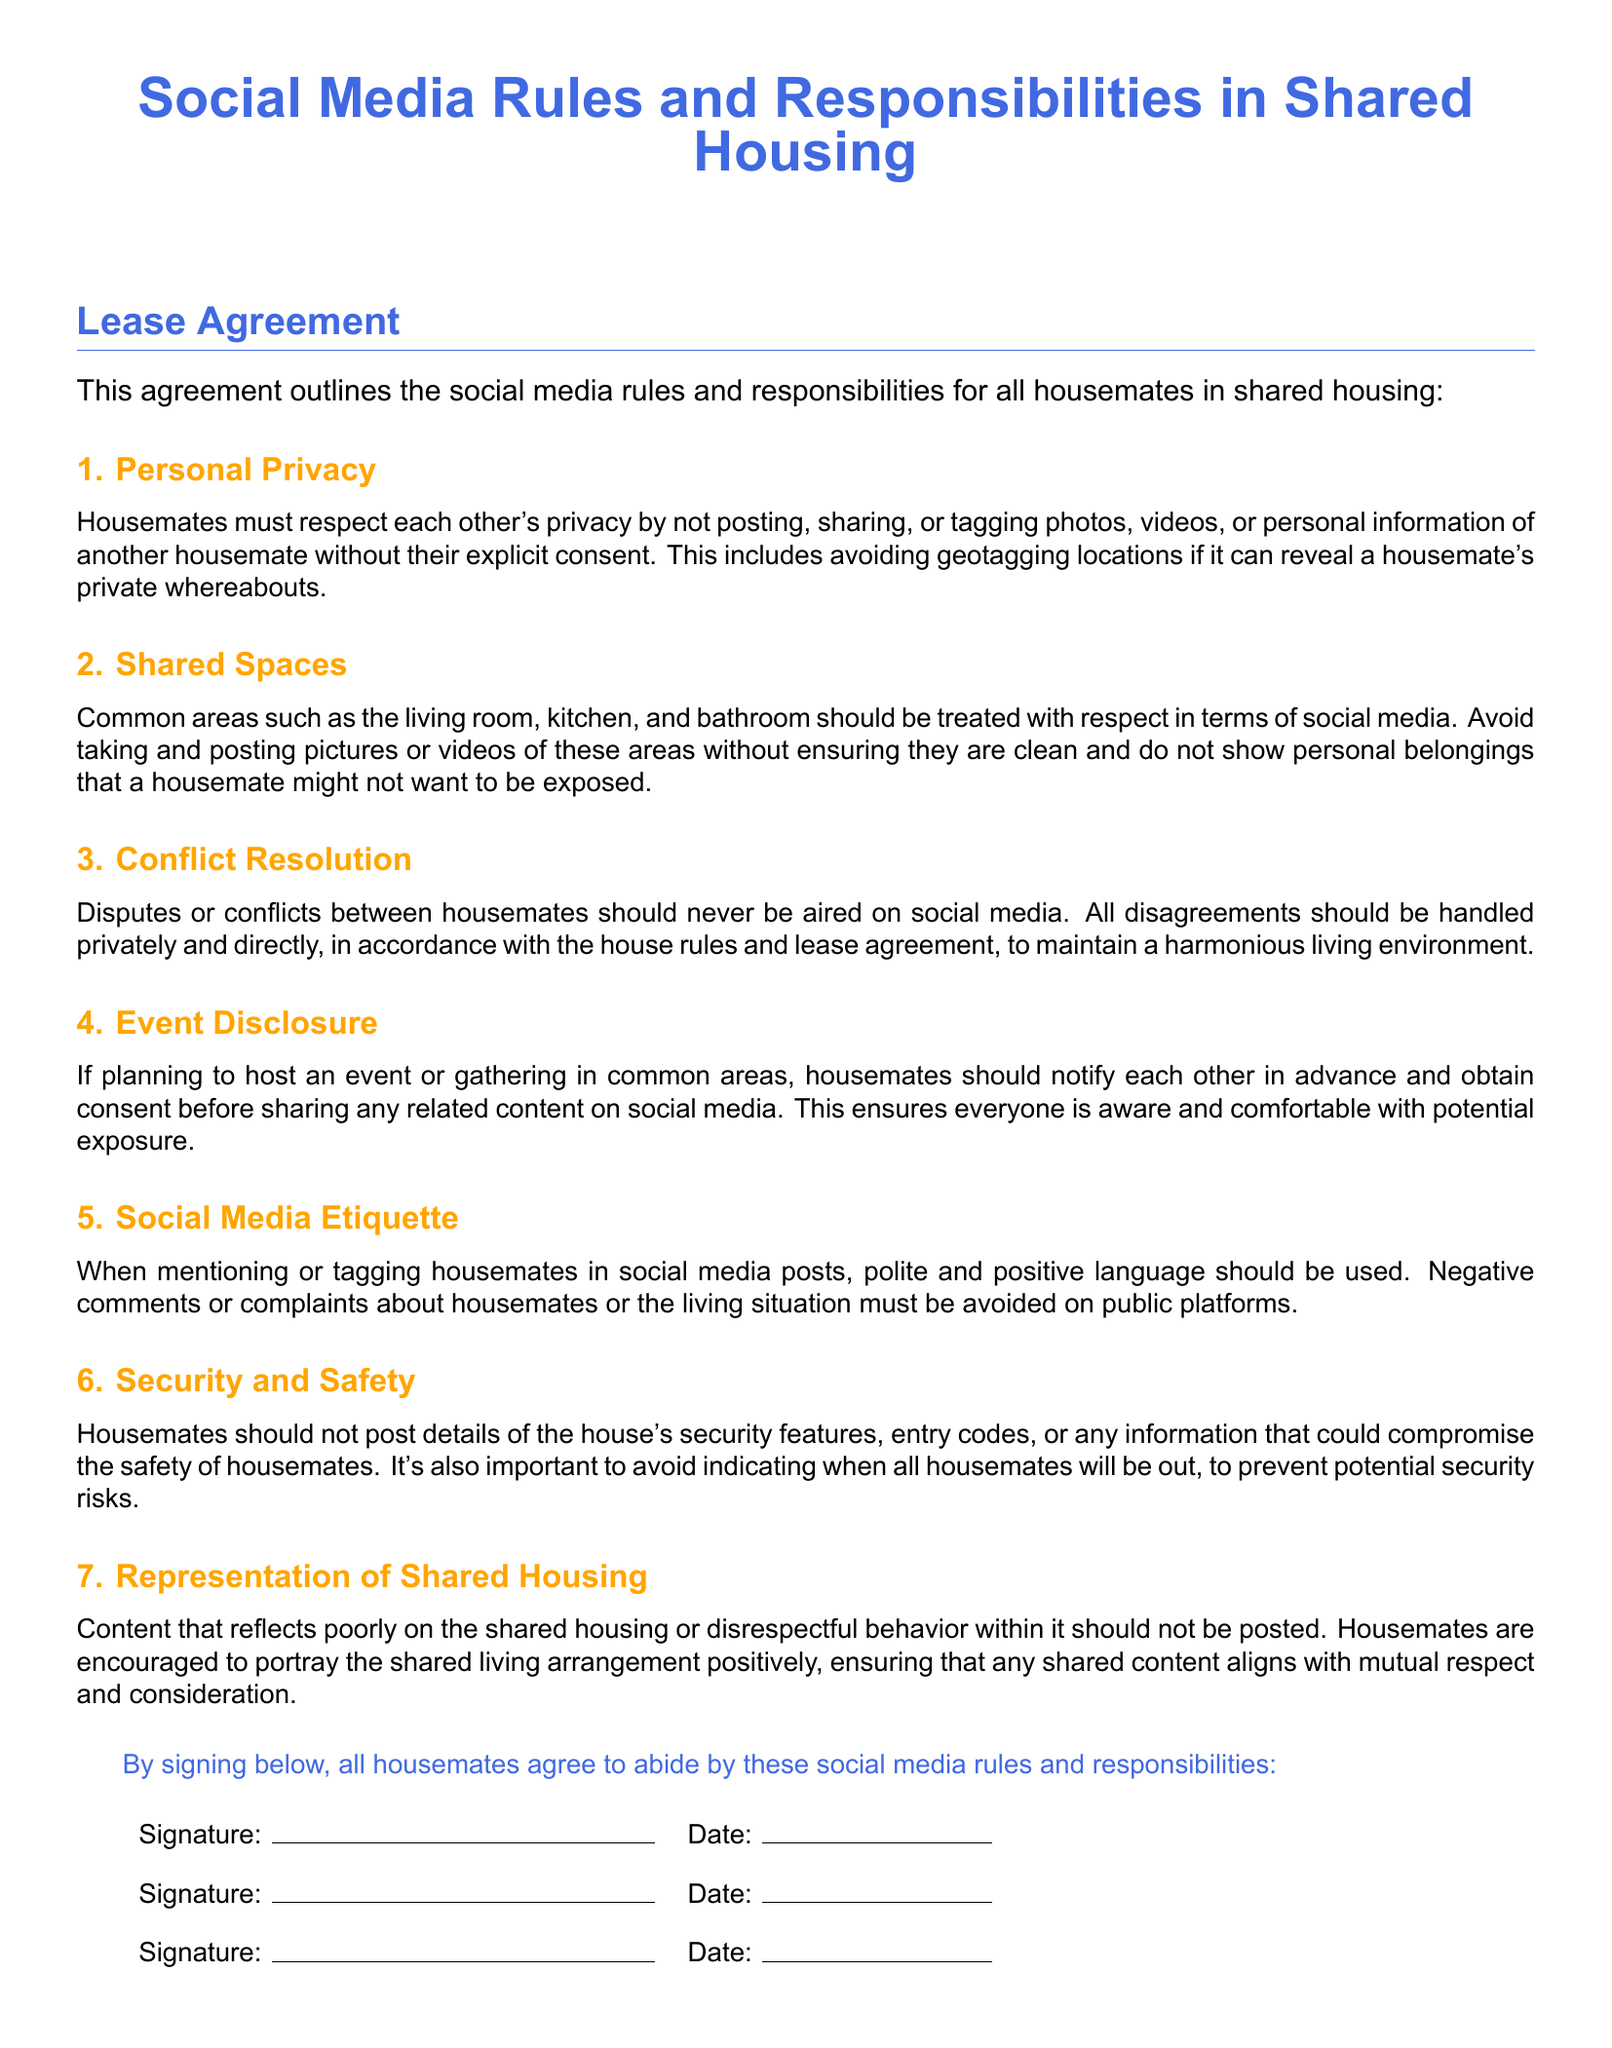What is the title of the document? The title of the document is stated at the top, summarizing its content regarding shared housing social media rules.
Answer: Social Media Rules and Responsibilities in Shared Housing How many sections are listed in the agreement? The document outlines seven specific sections regarding social media rules for housemates.
Answer: 7 What should housemates avoid posting without consent? The agreement emphasizes the importance of privacy and states that specific content should not be shared without permission.
Answer: Photos, videos, or personal information What must housemates do before sharing event-related content? Housemates are required to communicate and obtain consent regarding any event they plan to host in shared spaces.
Answer: Notify each other in advance What kind of language should be used when tagging housemates? The rules regarding social media etiquette indicate that comments should be both polite and constructive.
Answer: Polite and positive language What does the agreement say about disputes among housemates? It specifies that disputes should be handled privately and not aired on social media for a harmonious living situation.
Answer: Never be aired on social media Are housemates allowed to share security features? The document contains a specific rule that discourages sharing security information that could compromise housemate safety.
Answer: No 